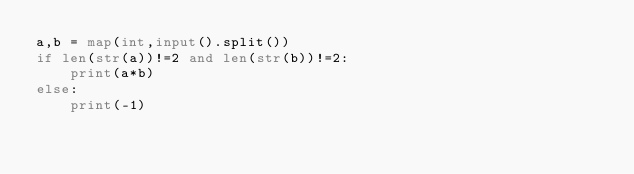<code> <loc_0><loc_0><loc_500><loc_500><_Python_>a,b = map(int,input().split())
if len(str(a))!=2 and len(str(b))!=2:
    print(a*b)
else:
    print(-1)</code> 